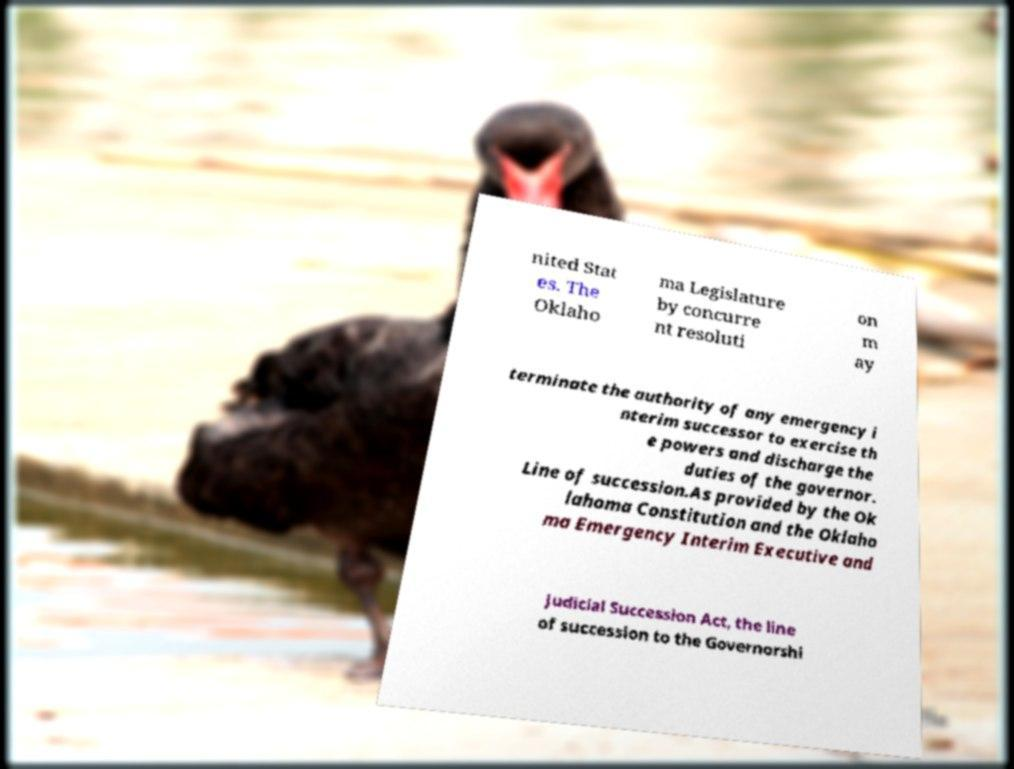Please read and relay the text visible in this image. What does it say? nited Stat es. The Oklaho ma Legislature by concurre nt resoluti on m ay terminate the authority of any emergency i nterim successor to exercise th e powers and discharge the duties of the governor. Line of succession.As provided by the Ok lahoma Constitution and the Oklaho ma Emergency Interim Executive and Judicial Succession Act, the line of succession to the Governorshi 